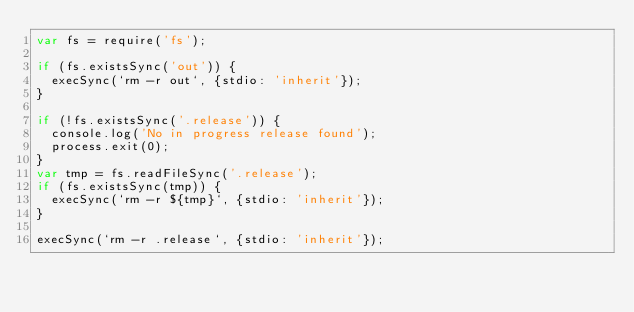<code> <loc_0><loc_0><loc_500><loc_500><_JavaScript_>var fs = require('fs');

if (fs.existsSync('out')) {
  execSync(`rm -r out`, {stdio: 'inherit'});
}

if (!fs.existsSync('.release')) {
  console.log('No in progress release found');
  process.exit(0);
}
var tmp = fs.readFileSync('.release');
if (fs.existsSync(tmp)) {
  execSync(`rm -r ${tmp}`, {stdio: 'inherit'});
}

execSync(`rm -r .release`, {stdio: 'inherit'});</code> 